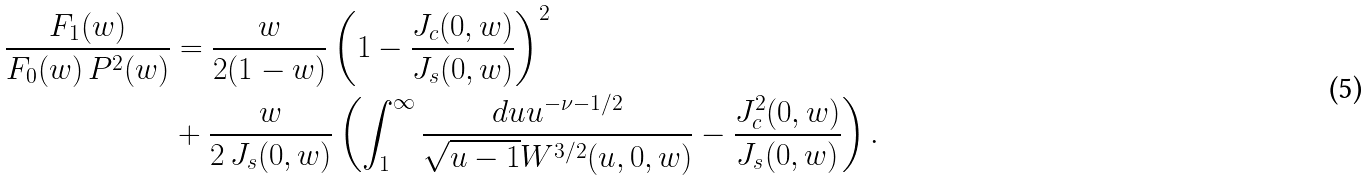Convert formula to latex. <formula><loc_0><loc_0><loc_500><loc_500>\frac { F _ { 1 } ( w ) } { F _ { 0 } ( w ) \, P ^ { 2 } ( w ) } & = \frac { w } { 2 ( 1 - w ) } \left ( 1 - \frac { J _ { c } ( 0 , w ) } { J _ { s } ( 0 , w ) } \right ) ^ { 2 } \\ & + \frac { w } { 2 \, J _ { s } ( 0 , w ) } \left ( \int ^ { \infty } _ { 1 } \frac { d u u ^ { - \nu - 1 / 2 } } { \sqrt { u - 1 } W ^ { 3 / 2 } ( u , 0 , w ) } - \frac { J _ { c } ^ { 2 } ( 0 , w ) } { J _ { s } ( 0 , w ) } \right ) .</formula> 